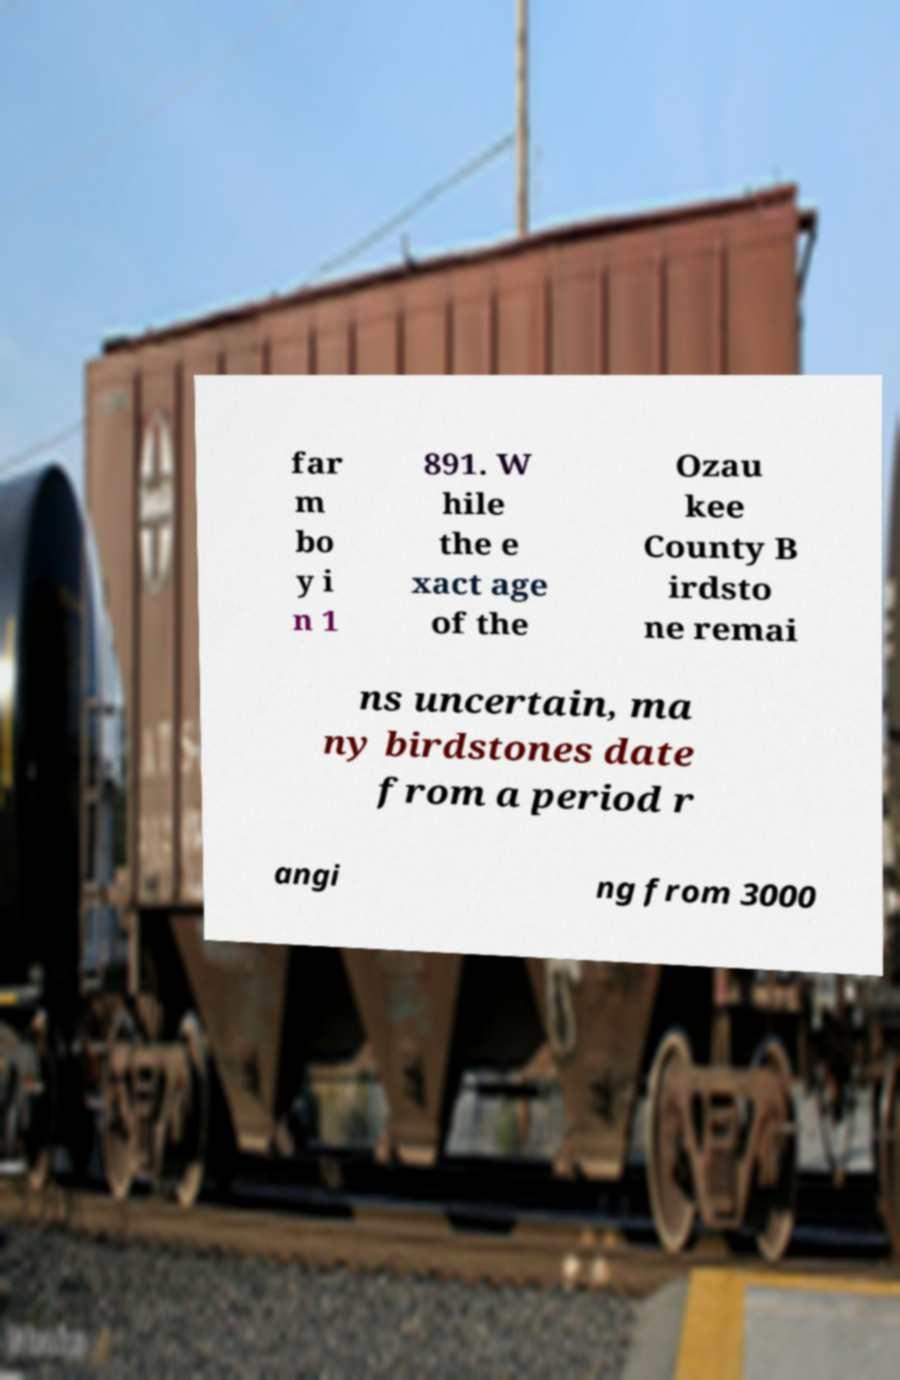Could you assist in decoding the text presented in this image and type it out clearly? far m bo y i n 1 891. W hile the e xact age of the Ozau kee County B irdsto ne remai ns uncertain, ma ny birdstones date from a period r angi ng from 3000 